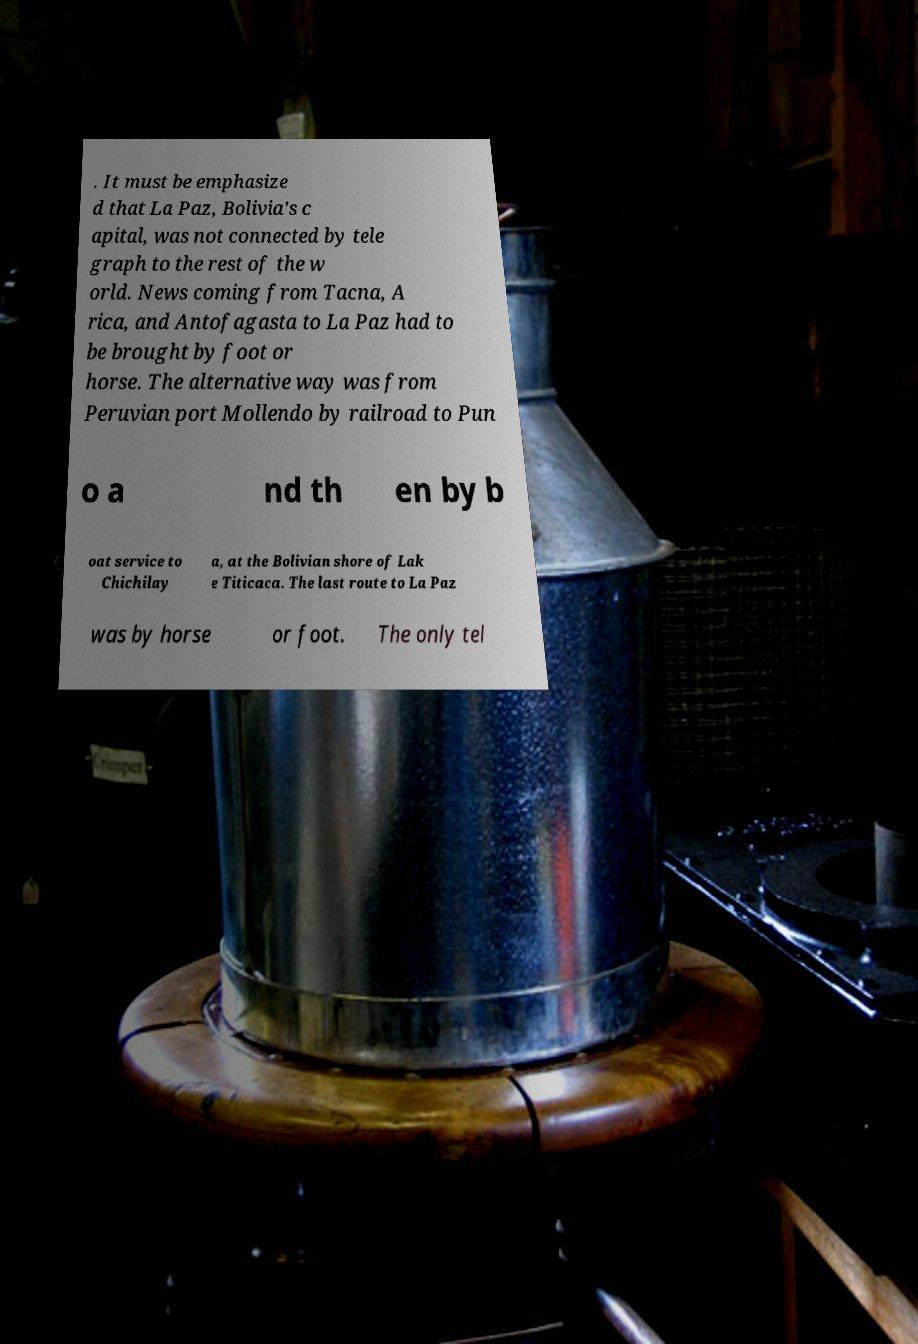Could you assist in decoding the text presented in this image and type it out clearly? . It must be emphasize d that La Paz, Bolivia's c apital, was not connected by tele graph to the rest of the w orld. News coming from Tacna, A rica, and Antofagasta to La Paz had to be brought by foot or horse. The alternative way was from Peruvian port Mollendo by railroad to Pun o a nd th en by b oat service to Chichilay a, at the Bolivian shore of Lak e Titicaca. The last route to La Paz was by horse or foot. The only tel 